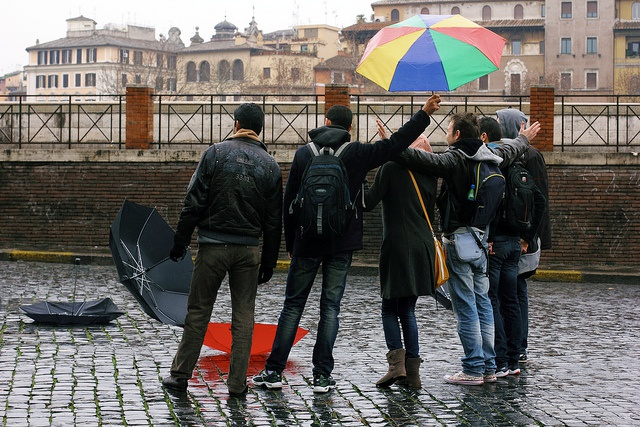Describe the objects in this image and their specific colors. I can see people in white, black, gray, darkgray, and purple tones, people in white, black, gray, darkgray, and purple tones, people in white, black, gray, darkgray, and blue tones, people in white, black, gray, olive, and maroon tones, and umbrella in white, aquamarine, lightpink, blue, and lightgray tones in this image. 